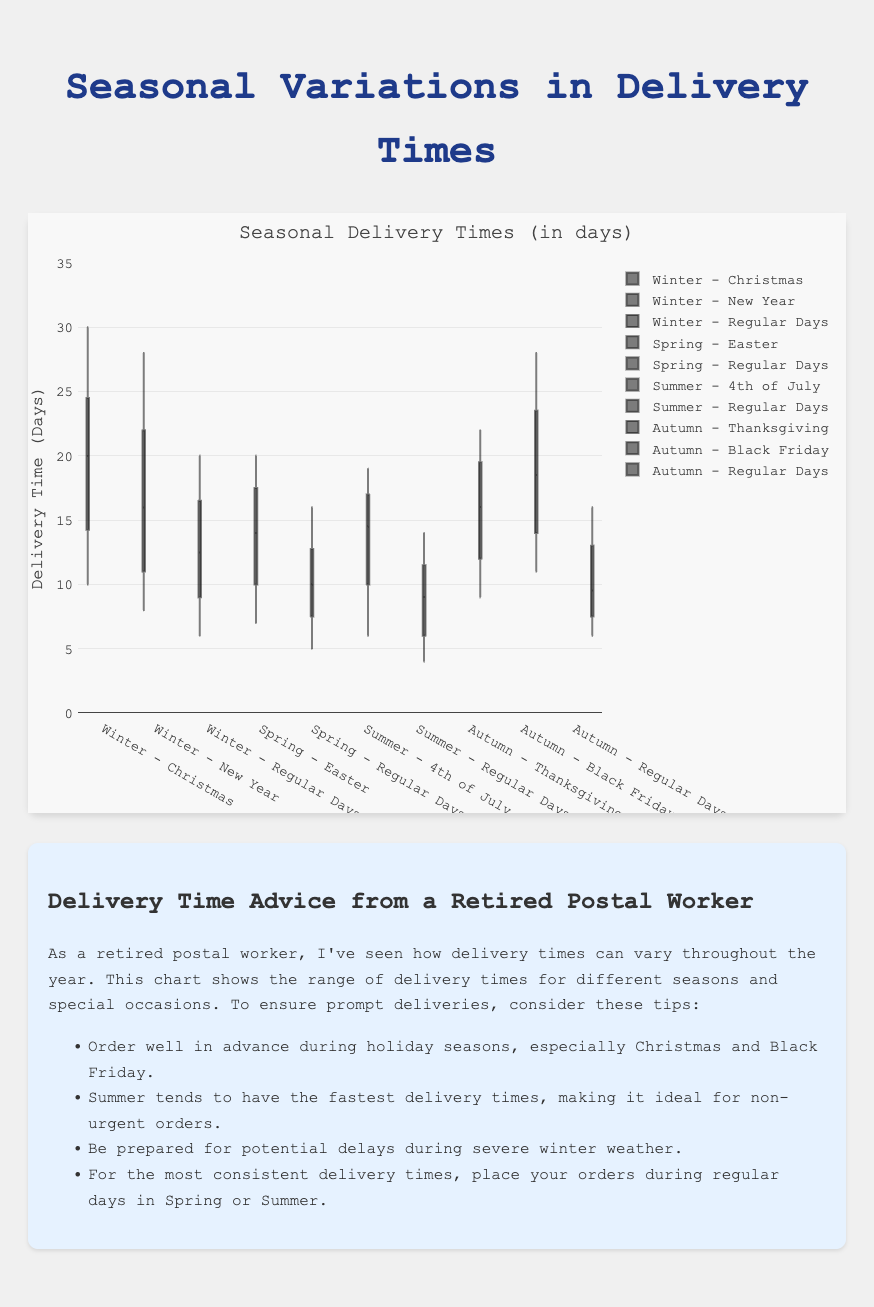What is the range of delivery times for Christmas in Winter? The range of delivery times is determined by the minimum and maximum values in the box plot for Christmas during Winter. The minimum is 10 days and the maximum is 30 days.
Answer: 10 to 30 days Which season generally has the fastest delivery times on regular days? To determine this, compare the medians or lower ranges of the delivery times for regular days across all seasons. Summer's median delivery time for regular days appears to be the lowest.
Answer: Summer What is the median delivery time for Black Friday in Autumn? The median delivery time is the middle value when the data points are arranged in order. From the data points (11, 13, 15, 17, 20, 22, 25, 28), the median is the average of the middle two values: (17 + 20)/2.
Answer: 18.5 days Between Christmas and New Year in Winter, which holiday has a shorter median delivery time? Compare the median delivery times shown in the box plots. The median for Christmas is around 20 days, while the median for New Year is also around 14 days.
Answer: New Year During which season and occasion do we see the largest variation in delivery times? The largest variation can be seen by looking at the longest whiskers in a box plot. Christmas in Winter has a range from 10 to 30 days, which is the largest span among all occasions.
Answer: Winter - Christmas Are regular delivery times more consistent in Spring or Autumn? Consistency can be measured by the interquartile range (IQR). Regular days in Spring have a more compact IQR compared to Autumn, indicating more consistent delivery times.
Answer: Spring Which season has the highest median delivery time for special occasions? Look at the medians of the special occasions across different seasons. Winter has the highest median delivery time for Christmas (around 20 days).
Answer: Winter How does the 4th of July delivery time compare to Easter delivery time? First, find the medians for each occasion. The median delivery time for the 4th of July is around 14 days, whereas for Easter it is around 13 days.
Answer: 4th of July is slightly longer Which set of holiday delivery times shows more outliers: Thanksgiving or Christmas? Outliers are represented by points outside the box plot whiskers. Both Christmas and Thanksgiving should be checked for any points falling outside the range. Christmas has no visible outliers, while Thanksgiving also does not seem to have any visible outliers.
Answer: Neither 